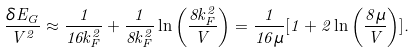Convert formula to latex. <formula><loc_0><loc_0><loc_500><loc_500>\frac { \delta E _ { G } } { V ^ { 2 } } \approx \frac { 1 } { 1 6 k _ { F } ^ { 2 } } + \frac { 1 } { 8 k _ { F } ^ { 2 } } \ln \left ( \frac { 8 k _ { F } ^ { 2 } } { V } \right ) = \frac { 1 } { 1 6 \mu } [ 1 + 2 \ln \left ( \frac { 8 \mu } { V } \right ) ] .</formula> 